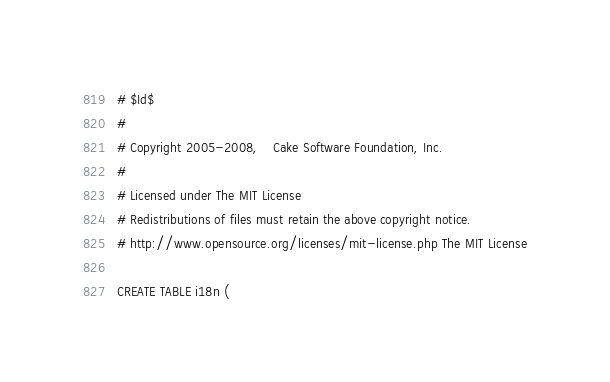<code> <loc_0><loc_0><loc_500><loc_500><_SQL_># $Id$
#
# Copyright 2005-2008,	Cake Software Foundation, Inc.
#
# Licensed under The MIT License
# Redistributions of files must retain the above copyright notice.
# http://www.opensource.org/licenses/mit-license.php The MIT License

CREATE TABLE i18n (</code> 